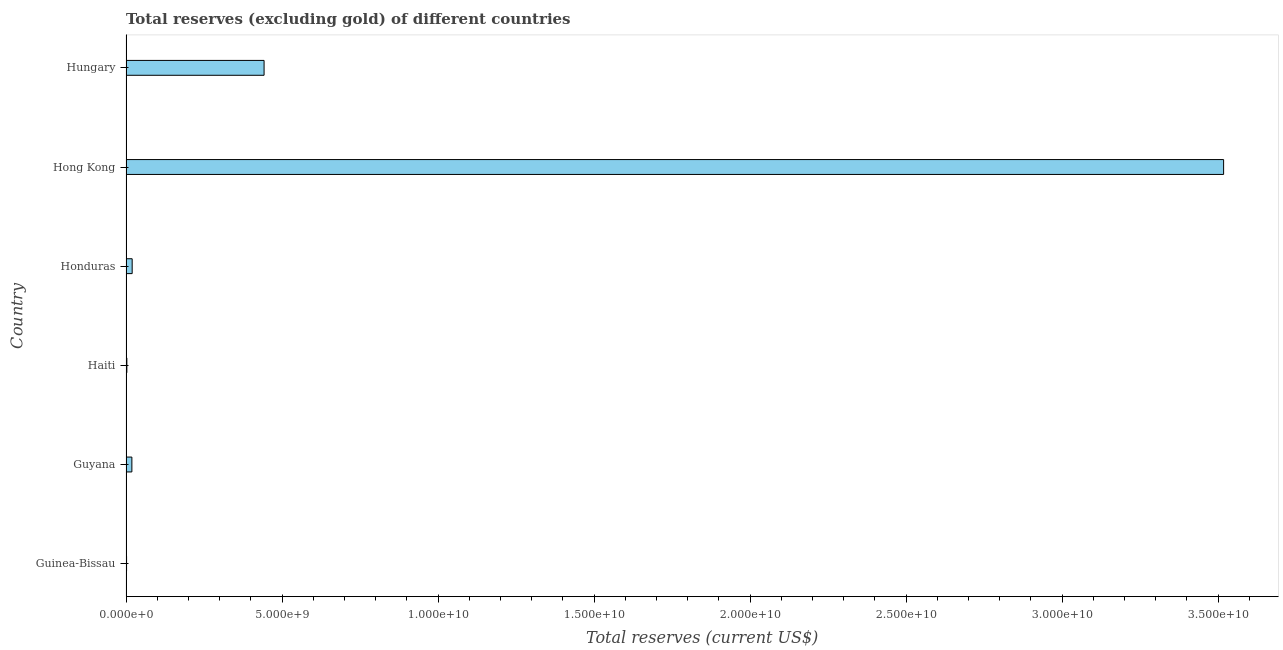Does the graph contain any zero values?
Offer a terse response. No. What is the title of the graph?
Keep it short and to the point. Total reserves (excluding gold) of different countries. What is the label or title of the X-axis?
Keep it short and to the point. Total reserves (current US$). What is the total reserves (excluding gold) in Hungary?
Your answer should be very brief. 4.42e+09. Across all countries, what is the maximum total reserves (excluding gold)?
Give a very brief answer. 3.52e+1. Across all countries, what is the minimum total reserves (excluding gold)?
Provide a succinct answer. 1.78e+07. In which country was the total reserves (excluding gold) maximum?
Your answer should be compact. Hong Kong. In which country was the total reserves (excluding gold) minimum?
Offer a very short reply. Guinea-Bissau. What is the sum of the total reserves (excluding gold)?
Your answer should be compact. 4.00e+1. What is the difference between the total reserves (excluding gold) in Haiti and Honduras?
Your response must be concise. -1.70e+08. What is the average total reserves (excluding gold) per country?
Keep it short and to the point. 6.67e+09. What is the median total reserves (excluding gold)?
Make the answer very short. 1.93e+08. In how many countries, is the total reserves (excluding gold) greater than 14000000000 US$?
Offer a terse response. 1. What is the ratio of the total reserves (excluding gold) in Guyana to that in Hong Kong?
Offer a very short reply. 0.01. What is the difference between the highest and the second highest total reserves (excluding gold)?
Your answer should be very brief. 3.07e+1. What is the difference between the highest and the lowest total reserves (excluding gold)?
Provide a short and direct response. 3.52e+1. How many bars are there?
Give a very brief answer. 6. Are all the bars in the graph horizontal?
Give a very brief answer. Yes. How many countries are there in the graph?
Offer a terse response. 6. What is the difference between two consecutive major ticks on the X-axis?
Ensure brevity in your answer.  5.00e+09. What is the Total reserves (current US$) in Guinea-Bissau?
Keep it short and to the point. 1.78e+07. What is the Total reserves (current US$) of Guyana?
Offer a very short reply. 1.88e+08. What is the Total reserves (current US$) of Haiti?
Make the answer very short. 2.71e+07. What is the Total reserves (current US$) of Honduras?
Provide a short and direct response. 1.97e+08. What is the Total reserves (current US$) in Hong Kong?
Keep it short and to the point. 3.52e+1. What is the Total reserves (current US$) of Hungary?
Provide a short and direct response. 4.42e+09. What is the difference between the Total reserves (current US$) in Guinea-Bissau and Guyana?
Your answer should be very brief. -1.70e+08. What is the difference between the Total reserves (current US$) in Guinea-Bissau and Haiti?
Ensure brevity in your answer.  -9.32e+06. What is the difference between the Total reserves (current US$) in Guinea-Bissau and Honduras?
Offer a very short reply. -1.80e+08. What is the difference between the Total reserves (current US$) in Guinea-Bissau and Hong Kong?
Your answer should be compact. -3.52e+1. What is the difference between the Total reserves (current US$) in Guinea-Bissau and Hungary?
Offer a very short reply. -4.41e+09. What is the difference between the Total reserves (current US$) in Guyana and Haiti?
Provide a short and direct response. 1.61e+08. What is the difference between the Total reserves (current US$) in Guyana and Honduras?
Provide a short and direct response. -9.37e+06. What is the difference between the Total reserves (current US$) in Guyana and Hong Kong?
Ensure brevity in your answer.  -3.50e+1. What is the difference between the Total reserves (current US$) in Guyana and Hungary?
Give a very brief answer. -4.24e+09. What is the difference between the Total reserves (current US$) in Haiti and Honduras?
Offer a very short reply. -1.70e+08. What is the difference between the Total reserves (current US$) in Haiti and Hong Kong?
Your answer should be compact. -3.51e+1. What is the difference between the Total reserves (current US$) in Haiti and Hungary?
Give a very brief answer. -4.40e+09. What is the difference between the Total reserves (current US$) in Honduras and Hong Kong?
Offer a terse response. -3.50e+1. What is the difference between the Total reserves (current US$) in Honduras and Hungary?
Offer a terse response. -4.23e+09. What is the difference between the Total reserves (current US$) in Hong Kong and Hungary?
Offer a terse response. 3.07e+1. What is the ratio of the Total reserves (current US$) in Guinea-Bissau to that in Guyana?
Make the answer very short. 0.09. What is the ratio of the Total reserves (current US$) in Guinea-Bissau to that in Haiti?
Keep it short and to the point. 0.66. What is the ratio of the Total reserves (current US$) in Guinea-Bissau to that in Honduras?
Offer a terse response. 0.09. What is the ratio of the Total reserves (current US$) in Guinea-Bissau to that in Hungary?
Make the answer very short. 0. What is the ratio of the Total reserves (current US$) in Guyana to that in Haiti?
Your answer should be compact. 6.95. What is the ratio of the Total reserves (current US$) in Guyana to that in Honduras?
Offer a very short reply. 0.95. What is the ratio of the Total reserves (current US$) in Guyana to that in Hong Kong?
Keep it short and to the point. 0.01. What is the ratio of the Total reserves (current US$) in Guyana to that in Hungary?
Your response must be concise. 0.04. What is the ratio of the Total reserves (current US$) in Haiti to that in Honduras?
Offer a very short reply. 0.14. What is the ratio of the Total reserves (current US$) in Haiti to that in Hungary?
Your answer should be very brief. 0.01. What is the ratio of the Total reserves (current US$) in Honduras to that in Hong Kong?
Make the answer very short. 0.01. What is the ratio of the Total reserves (current US$) in Honduras to that in Hungary?
Ensure brevity in your answer.  0.04. What is the ratio of the Total reserves (current US$) in Hong Kong to that in Hungary?
Provide a succinct answer. 7.95. 